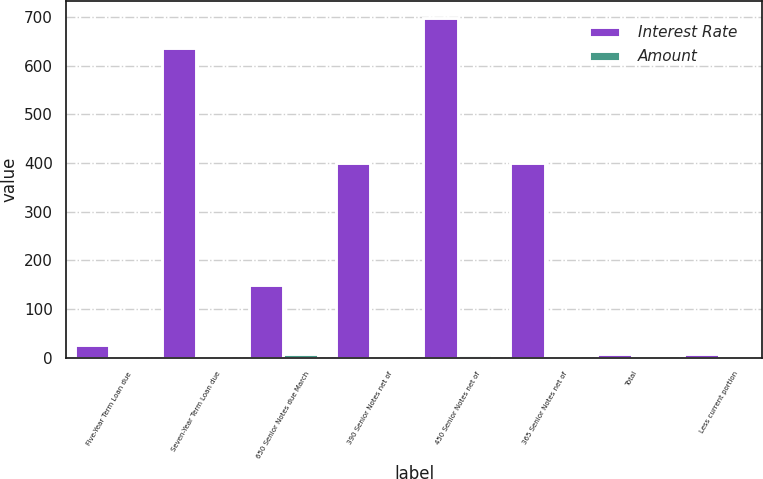Convert chart to OTSL. <chart><loc_0><loc_0><loc_500><loc_500><stacked_bar_chart><ecel><fcel>Five-Year Term Loan due<fcel>Seven-Year Term Loan due<fcel>650 Senior Notes due March<fcel>390 Senior Notes net of<fcel>450 Senior Notes net of<fcel>365 Senior Notes net of<fcel>Total<fcel>Less current portion<nl><fcel>Interest Rate<fcel>25<fcel>637<fcel>150<fcel>399.7<fcel>698.5<fcel>399<fcel>6.5<fcel>6.5<nl><fcel>Amount<fcel>1.8<fcel>2.05<fcel>6.5<fcel>3.9<fcel>4.5<fcel>3.65<fcel>3.67<fcel>2.05<nl></chart> 